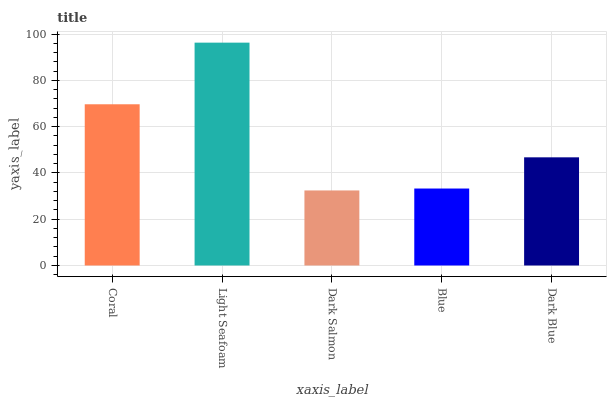Is Light Seafoam the minimum?
Answer yes or no. No. Is Dark Salmon the maximum?
Answer yes or no. No. Is Light Seafoam greater than Dark Salmon?
Answer yes or no. Yes. Is Dark Salmon less than Light Seafoam?
Answer yes or no. Yes. Is Dark Salmon greater than Light Seafoam?
Answer yes or no. No. Is Light Seafoam less than Dark Salmon?
Answer yes or no. No. Is Dark Blue the high median?
Answer yes or no. Yes. Is Dark Blue the low median?
Answer yes or no. Yes. Is Dark Salmon the high median?
Answer yes or no. No. Is Light Seafoam the low median?
Answer yes or no. No. 